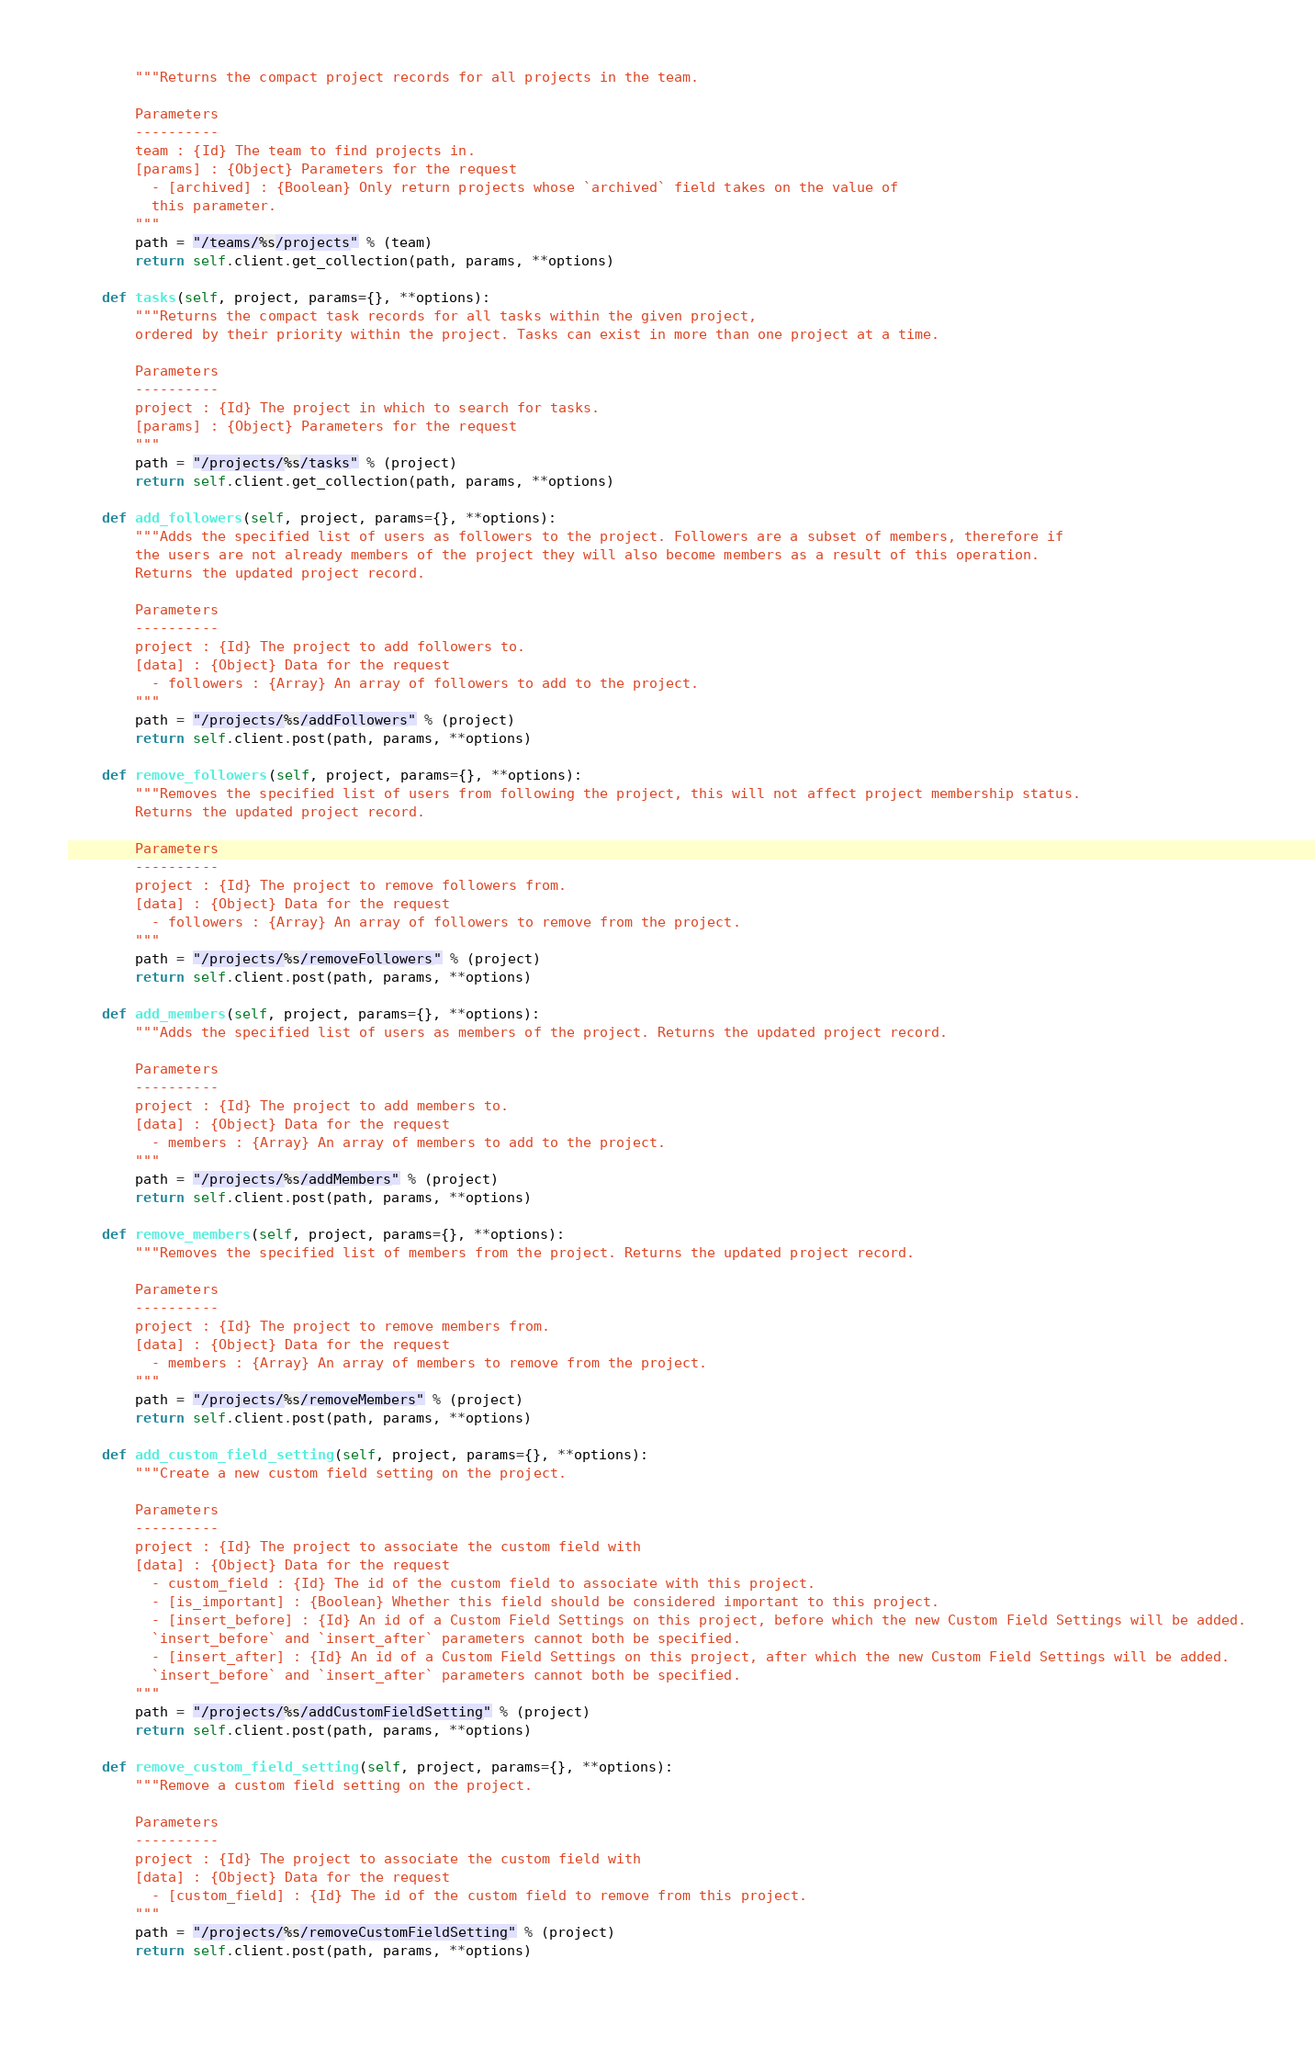Convert code to text. <code><loc_0><loc_0><loc_500><loc_500><_Python_>        """Returns the compact project records for all projects in the team.

        Parameters
        ----------
        team : {Id} The team to find projects in.
        [params] : {Object} Parameters for the request
          - [archived] : {Boolean} Only return projects whose `archived` field takes on the value of
          this parameter.
        """
        path = "/teams/%s/projects" % (team)
        return self.client.get_collection(path, params, **options)
        
    def tasks(self, project, params={}, **options): 
        """Returns the compact task records for all tasks within the given project,
        ordered by their priority within the project. Tasks can exist in more than one project at a time.

        Parameters
        ----------
        project : {Id} The project in which to search for tasks.
        [params] : {Object} Parameters for the request
        """
        path = "/projects/%s/tasks" % (project)
        return self.client.get_collection(path, params, **options)
        
    def add_followers(self, project, params={}, **options): 
        """Adds the specified list of users as followers to the project. Followers are a subset of members, therefore if
        the users are not already members of the project they will also become members as a result of this operation.
        Returns the updated project record.

        Parameters
        ----------
        project : {Id} The project to add followers to.
        [data] : {Object} Data for the request
          - followers : {Array} An array of followers to add to the project.
        """
        path = "/projects/%s/addFollowers" % (project)
        return self.client.post(path, params, **options)
        
    def remove_followers(self, project, params={}, **options): 
        """Removes the specified list of users from following the project, this will not affect project membership status.
        Returns the updated project record.

        Parameters
        ----------
        project : {Id} The project to remove followers from.
        [data] : {Object} Data for the request
          - followers : {Array} An array of followers to remove from the project.
        """
        path = "/projects/%s/removeFollowers" % (project)
        return self.client.post(path, params, **options)
        
    def add_members(self, project, params={}, **options): 
        """Adds the specified list of users as members of the project. Returns the updated project record.

        Parameters
        ----------
        project : {Id} The project to add members to.
        [data] : {Object} Data for the request
          - members : {Array} An array of members to add to the project.
        """
        path = "/projects/%s/addMembers" % (project)
        return self.client.post(path, params, **options)
        
    def remove_members(self, project, params={}, **options): 
        """Removes the specified list of members from the project. Returns the updated project record.

        Parameters
        ----------
        project : {Id} The project to remove members from.
        [data] : {Object} Data for the request
          - members : {Array} An array of members to remove from the project.
        """
        path = "/projects/%s/removeMembers" % (project)
        return self.client.post(path, params, **options)
        
    def add_custom_field_setting(self, project, params={}, **options): 
        """Create a new custom field setting on the project.

        Parameters
        ----------
        project : {Id} The project to associate the custom field with
        [data] : {Object} Data for the request
          - custom_field : {Id} The id of the custom field to associate with this project.
          - [is_important] : {Boolean} Whether this field should be considered important to this project.
          - [insert_before] : {Id} An id of a Custom Field Settings on this project, before which the new Custom Field Settings will be added.
          `insert_before` and `insert_after` parameters cannot both be specified.
          - [insert_after] : {Id} An id of a Custom Field Settings on this project, after which the new Custom Field Settings will be added.
          `insert_before` and `insert_after` parameters cannot both be specified.
        """
        path = "/projects/%s/addCustomFieldSetting" % (project)
        return self.client.post(path, params, **options)
        
    def remove_custom_field_setting(self, project, params={}, **options): 
        """Remove a custom field setting on the project.

        Parameters
        ----------
        project : {Id} The project to associate the custom field with
        [data] : {Object} Data for the request
          - [custom_field] : {Id} The id of the custom field to remove from this project.
        """
        path = "/projects/%s/removeCustomFieldSetting" % (project)
        return self.client.post(path, params, **options)
        
</code> 